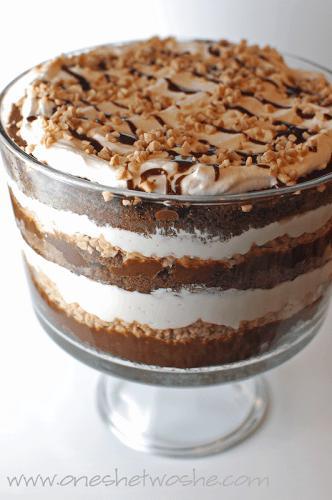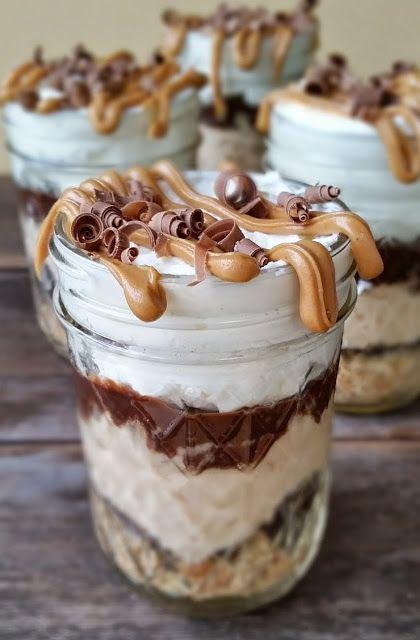The first image is the image on the left, the second image is the image on the right. For the images displayed, is the sentence "The dessert in the image on the right is sitting on a wooden surface." factually correct? Answer yes or no. Yes. 